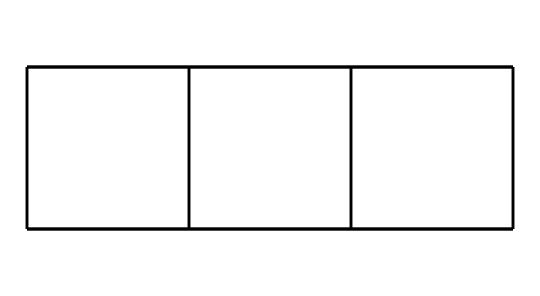What is the molecular formula of cubane? The SMILES representation indicates there are eight carbon atoms (C) and twelve hydrogen atoms (H), leading to the molecular formula C8H12.
Answer: C8H12 How many carbon atoms are in cubane? By analyzing the SMILES, we can count the number of carbon (C) atoms present; there are eight carbon atoms in the structure.
Answer: 8 What type of hybridization do the carbon atoms in cubane undergo? In cubane, the carbon atoms are all sp3 hybridized due to the tetrahedral geometry caused by four single bonds to neighboring atoms.
Answer: sp3 What characteristic features define cubane as a cage compound? The defining feature of cubane as a cage compound is its 3D structure with all carbon atoms interconnected in a closed ring, leading to significant angle strain.
Answer: 3D structure Why does cubane exhibit significant strain in its structure? The tetrahedral angle of 109.5 degrees is forced into a smaller angle of 90 degrees in cubane, creating angle strain due to the distortion from ideal bond angles.
Answer: Angle strain What is the bond angle in cubane around each carbon? The bond angles in cubane are about 90 degrees due to the geometry of how the carbon atoms are arranged in the cage structure.
Answer: 90 degrees 